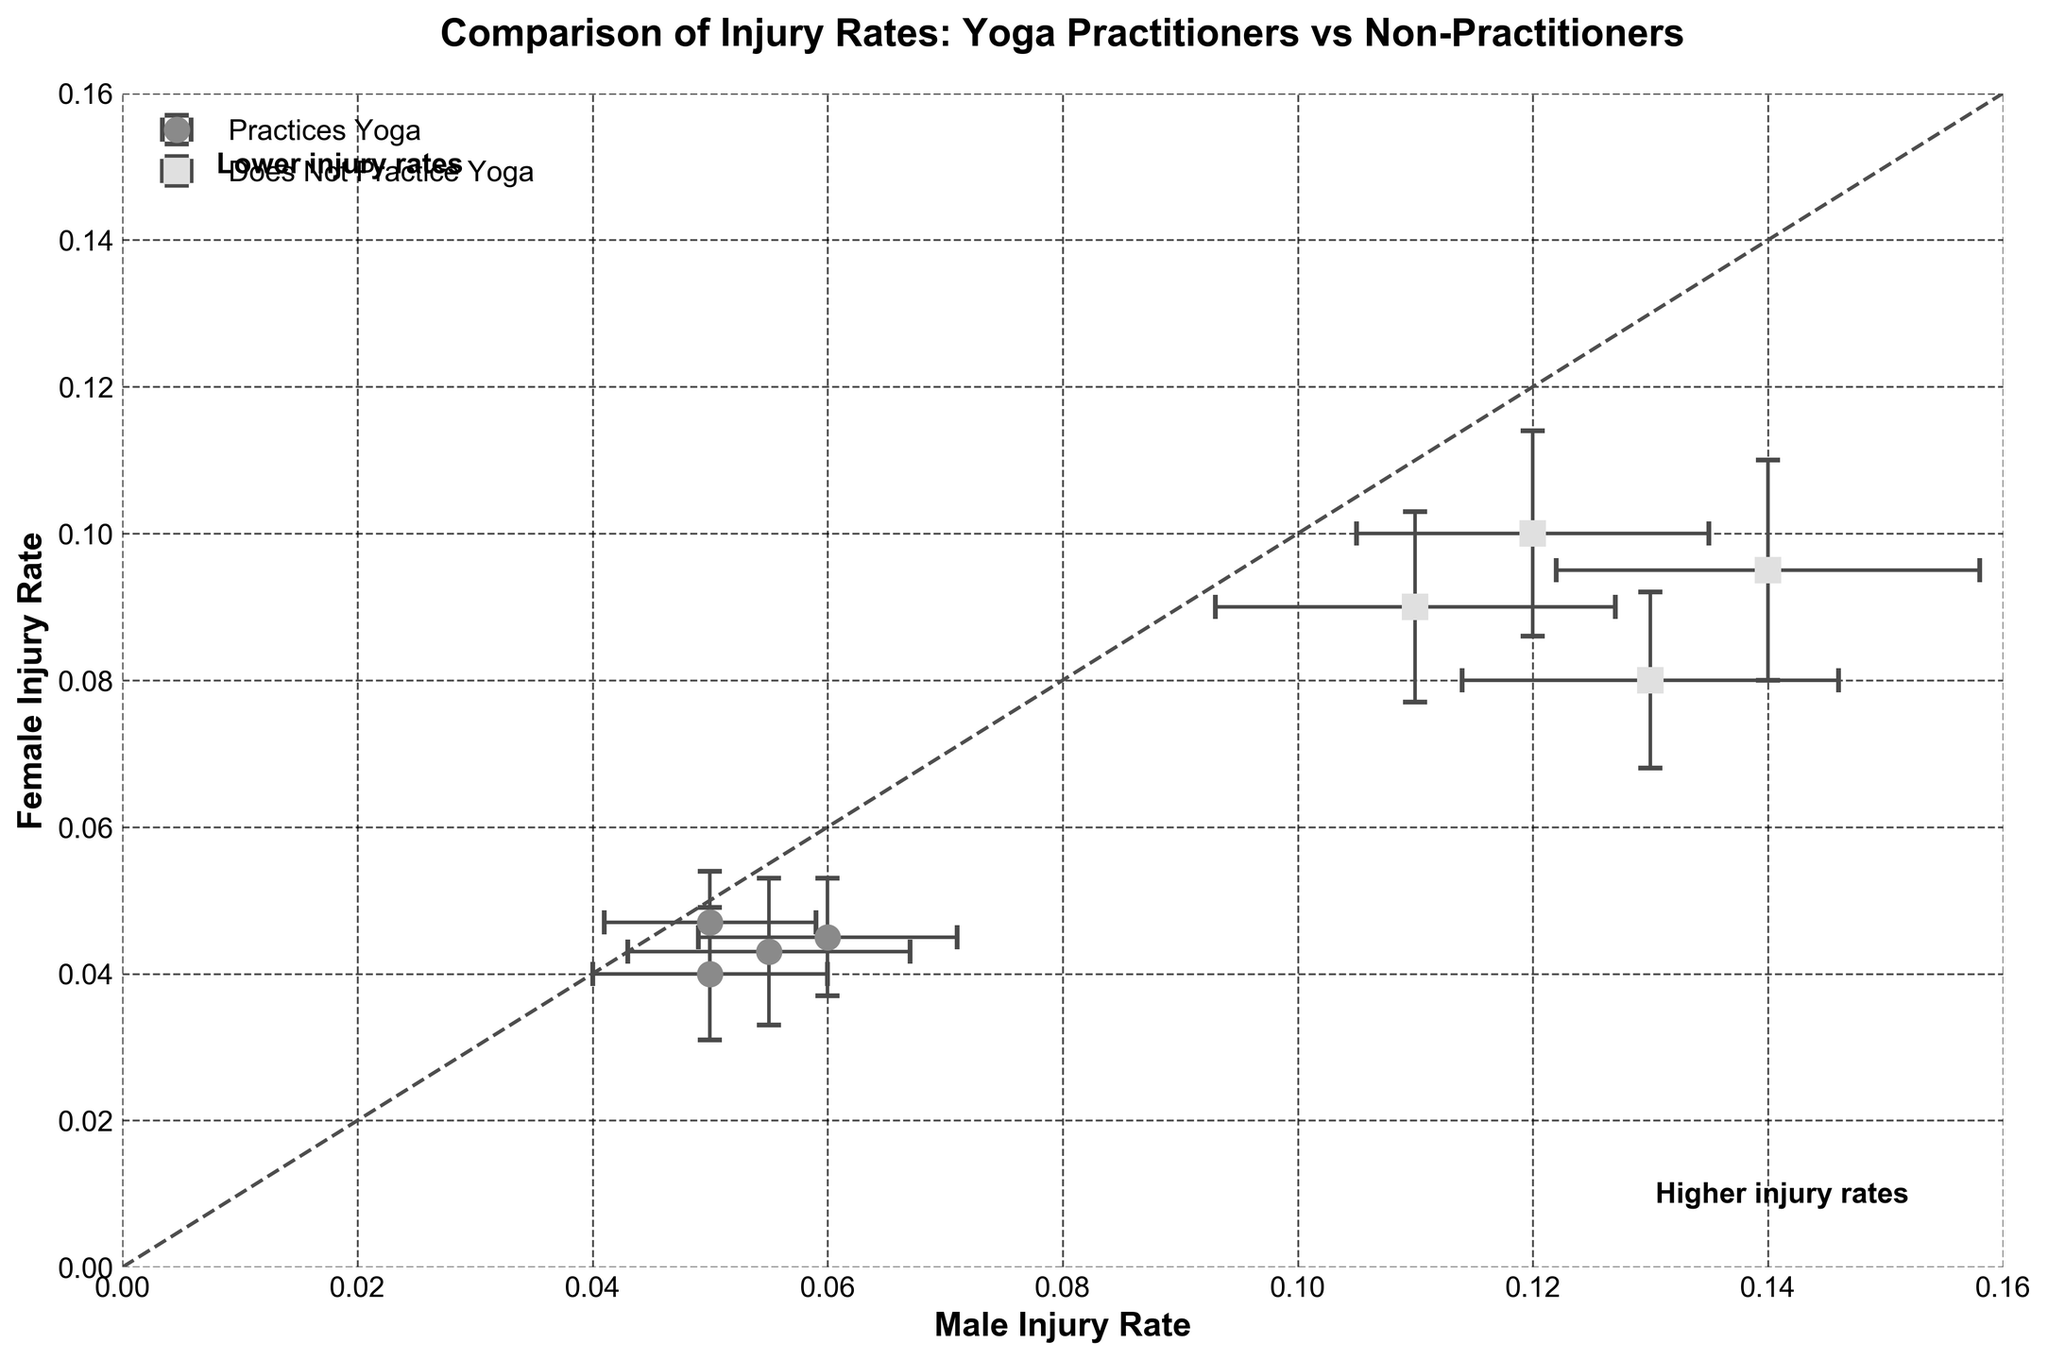What is the title of the figure? The title is located at the top of the figure.
Answer: Comparison of Injury Rates: Yoga Practitioners vs Non-Practitioners How many groups of athletes are compared in the plot? The figure has two groups labeled in the legend: one for "Practices Yoga" and one for "Does Not Practice Yoga."
Answer: 2 What does the label on the x-axis represent? The label on the x-axis is "Male Injury Rate," indicating it shows the injury rates for male athletes.
Answer: Male Injury Rate What are the symbols used to represent athletes who practice yoga and those who don't? The legend shows circles 'o' for "Practices Yoga" and squares 's' for "Does Not Practice Yoga."
Answer: Circles for Yoga, Squares for No Yoga What are the maximum and minimum injury rates for male athletes who do not practice yoga? The x-coordinates of the squares represent the injury rates for male athletes. The maximum rate for males not practicing yoga is 0.14, and the minimum is 0.11.
Answer: Maximum: 0.14, Minimum: 0.11 Which group has the overall higher injury rates, and how can you tell? By comparing the positions of the symbols, the squares (non-yoga practitioners) are generally further to the right (higher male injury rates) and higher up (higher female injury rates) than the circles (yoga practitioners).
Answer: Non-Yoga Practitioners What can you infer about injury rates among yoga-practicing female athletes compared to non-practicing female athletes? The y-coordinates show injury rates for females. Circles (yoga practitioners) are clustered lower on the y-axis compared to squares (non-practitioners), implying lower injury rates.
Answer: Lower injury rates for Yoga Practitioners Is there a trend seen in the plotted data with respect to yoga practice and injury rates for both genders? Yoga practitioners (circles) tend to have lower injury rates plotted closer to the origin. Non-practitioners (squares) show higher injury rates further from the origin on both axes.
Answer: Yoga practice correlates with lower injury rates What do the error bars represent in the scatter plot? The horizontal and vertical lines extending from the data points indicate the standard errors of the injury rates for males and females, respectively.
Answer: Standard errors Do male or female athletes who do not practice yoga have a more consistent (less variable) injury rate? By observing the lengths of the horizontal and vertical error bars for squares (non-yoga), the error bars for males are slightly more consistent in length than for females.
Answer: Male athletes 